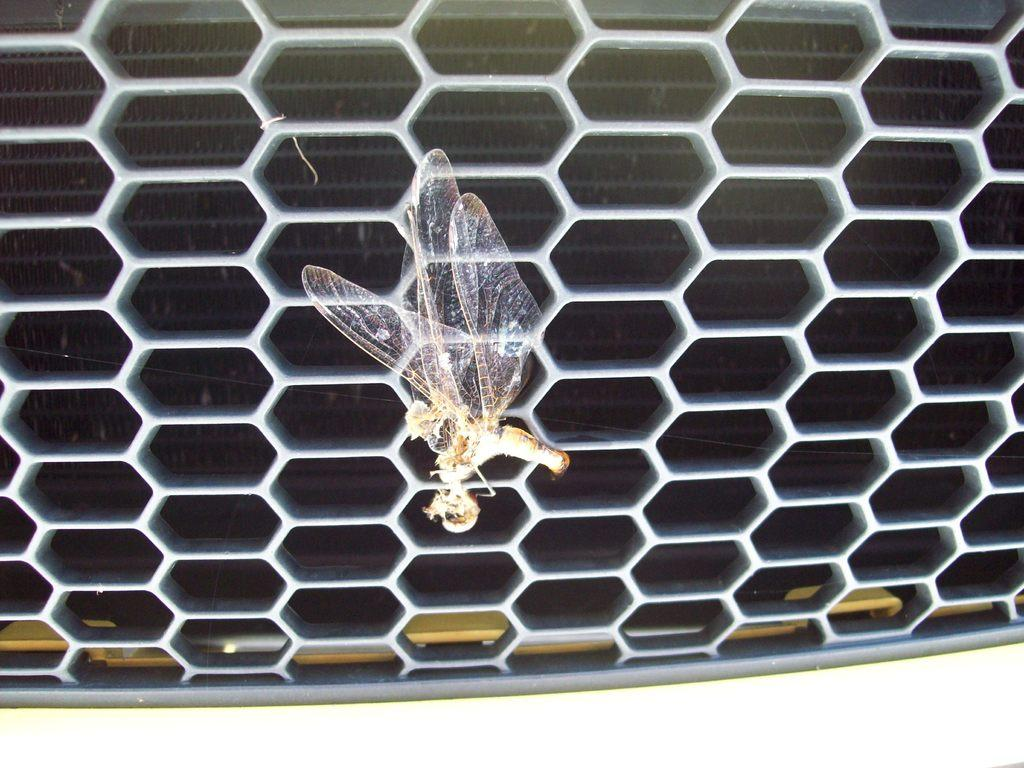What type of insect can be seen in the image? There is a dragonfly in the image. What structure is present in the image? There is a fence in the image. What color is the wall visible in the image? The wall in the image is black. What type of needle is being used by the family in the image? There is no needle or family present in the image; it features a dragonfly, a fence, and a black wall. 